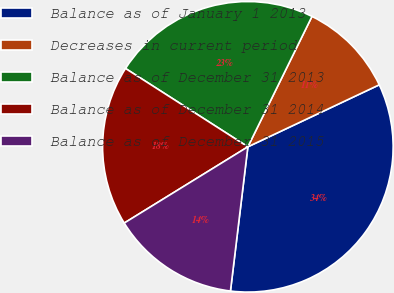<chart> <loc_0><loc_0><loc_500><loc_500><pie_chart><fcel>Balance as of January 1 2013<fcel>Decreases in current period<fcel>Balance as of December 31 2013<fcel>Balance as of December 31 2014<fcel>Balance as of December 31 2015<nl><fcel>33.93%<fcel>10.71%<fcel>23.21%<fcel>17.86%<fcel>14.29%<nl></chart> 